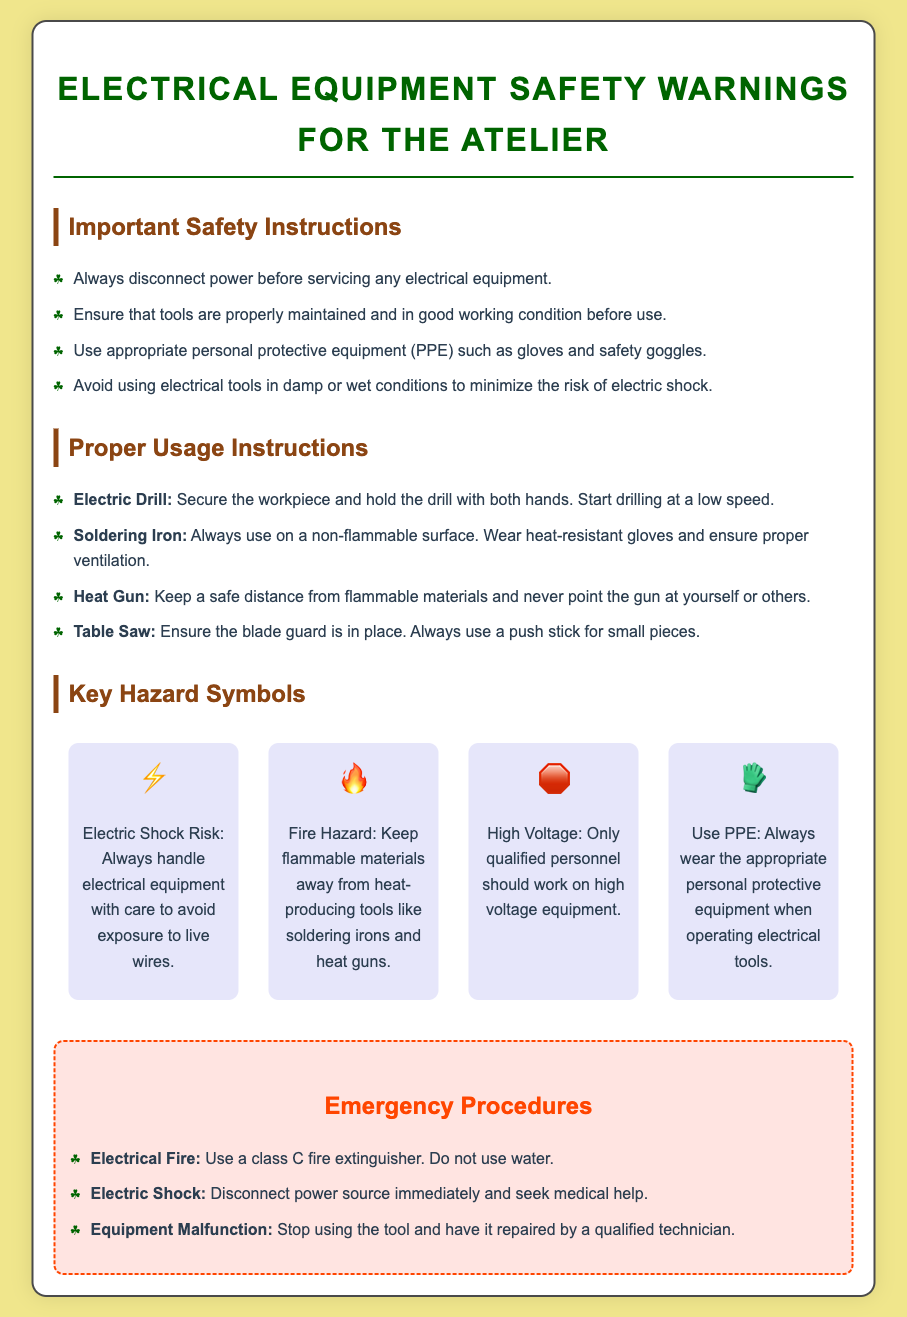What should you do before servicing electrical equipment? The document states you should always disconnect the power before servicing any electrical equipment.
Answer: Disconnect power What personal protective equipment is recommended? The document mentions using appropriate personal protective equipment (PPE) such as gloves and safety goggles.
Answer: Gloves and safety goggles What is a key hazard symbol for electric shock risk? The symbol for electric shock risk is represented by the icon ⚡.
Answer: ⚡ What should you keep away from heat-producing tools? The document advises keeping flammable materials away from heat-producing tools.
Answer: Flammable materials What type of fire extinguisher should be used for electrical fires? For electrical fires, the document specifies using a class C fire extinguisher.
Answer: Class C What tool requires using a push stick for small pieces? The document states that a table saw requires using a push stick for small pieces.
Answer: Table saw What is a safety instruction for using electrical tools? One safety instruction is to avoid using electrical tools in damp or wet conditions to minimize the risk of electric shock.
Answer: Avoid damp or wet conditions Who should work on high voltage equipment? The document indicates that only qualified personnel should work on high voltage equipment.
Answer: Qualified personnel 